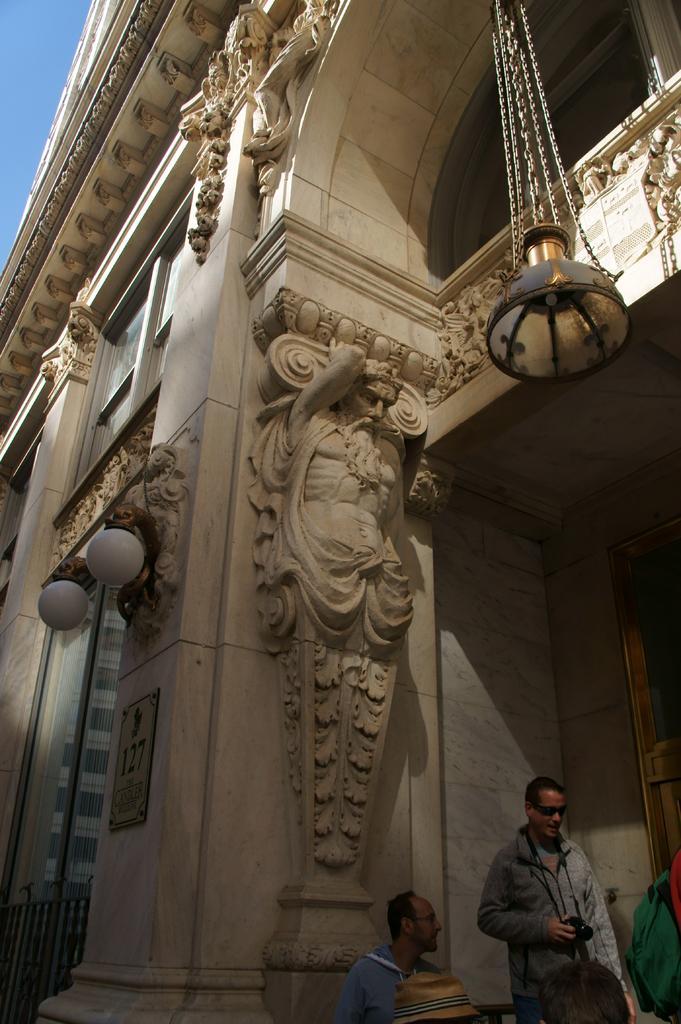Can you describe this image briefly? In the center of the image we can see building and light hanging from the wall. At the bottom there are persons. In the background there is wall. 